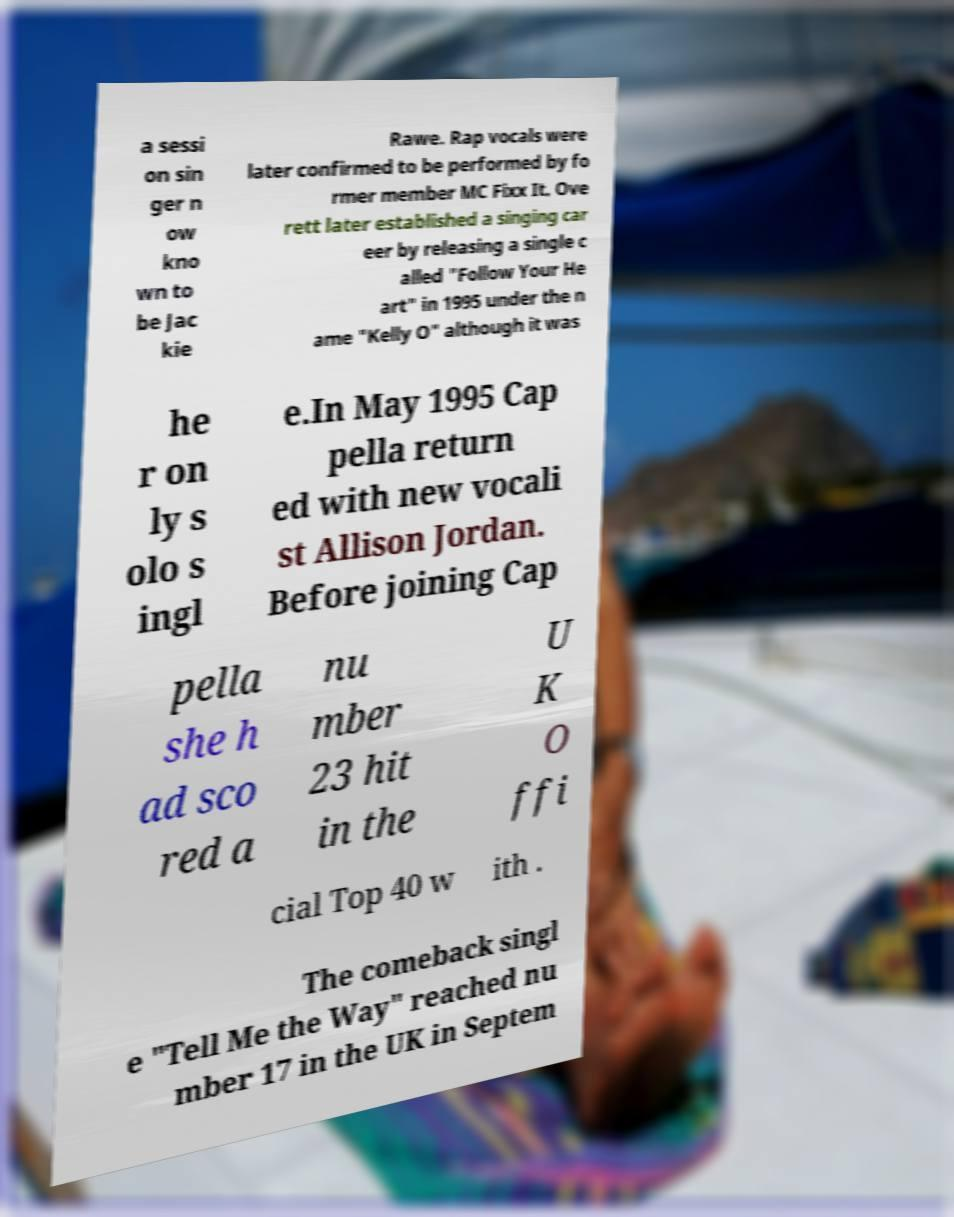For documentation purposes, I need the text within this image transcribed. Could you provide that? a sessi on sin ger n ow kno wn to be Jac kie Rawe. Rap vocals were later confirmed to be performed by fo rmer member MC Fixx It. Ove rett later established a singing car eer by releasing a single c alled "Follow Your He art" in 1995 under the n ame "Kelly O" although it was he r on ly s olo s ingl e.In May 1995 Cap pella return ed with new vocali st Allison Jordan. Before joining Cap pella she h ad sco red a nu mber 23 hit in the U K O ffi cial Top 40 w ith . The comeback singl e "Tell Me the Way" reached nu mber 17 in the UK in Septem 